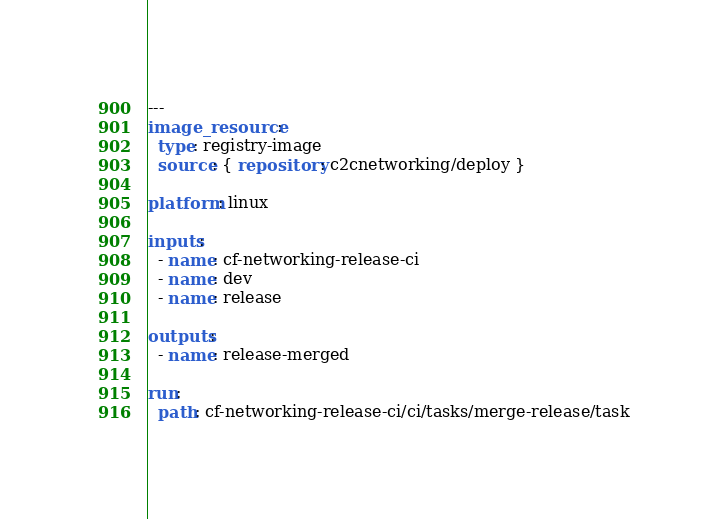<code> <loc_0><loc_0><loc_500><loc_500><_YAML_>---
image_resource:
  type: registry-image
  source: { repository: c2cnetworking/deploy }

platform: linux

inputs:
  - name: cf-networking-release-ci
  - name: dev
  - name: release

outputs:
  - name: release-merged

run:
  path: cf-networking-release-ci/ci/tasks/merge-release/task
</code> 